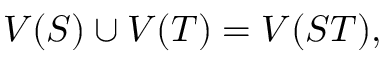<formula> <loc_0><loc_0><loc_500><loc_500>V ( S ) \cup V ( T ) = V ( S T ) ,</formula> 